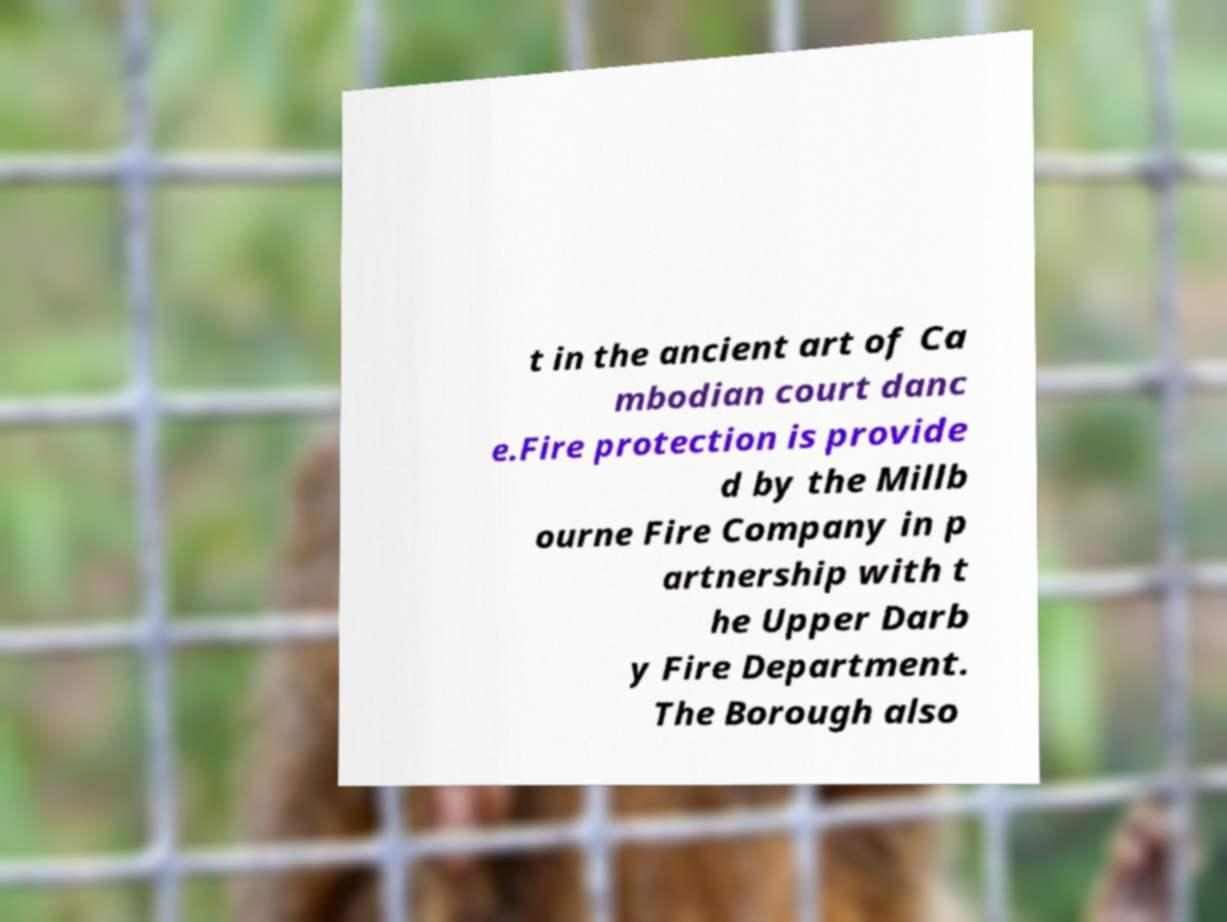I need the written content from this picture converted into text. Can you do that? t in the ancient art of Ca mbodian court danc e.Fire protection is provide d by the Millb ourne Fire Company in p artnership with t he Upper Darb y Fire Department. The Borough also 